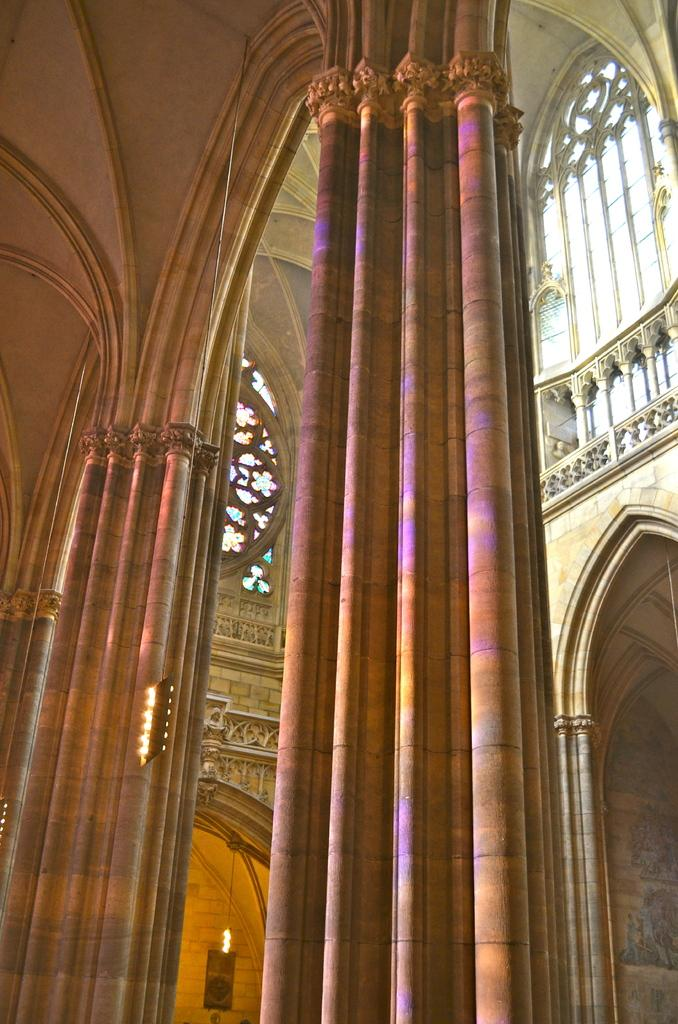What type of structure is visible in the image? There is a building in the image. How is the building depicted in the image? The building appears to be truncated. What architectural features can be seen in the image? There are pillars in the image. What is happening in the image? There is fire in the image. What is present on the wall in the image? There is a wall in the image, and there is a painting on the wall. What type of crown is depicted in the painting on the wall? There is no crown present in the image; the painting on the wall does not depict a crown. 